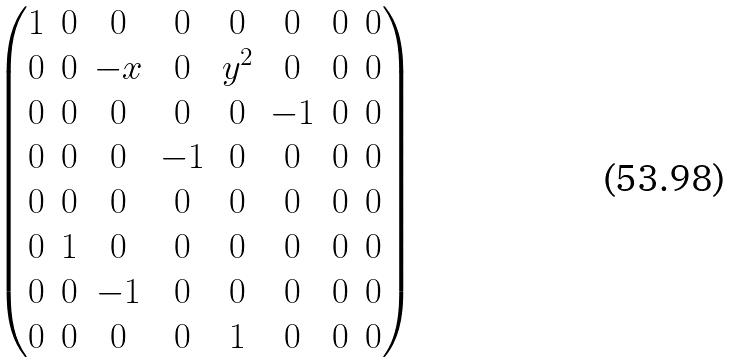Convert formula to latex. <formula><loc_0><loc_0><loc_500><loc_500>\begin{pmatrix} 1 & 0 & 0 & 0 & 0 & 0 & 0 & 0 \\ 0 & 0 & - x & 0 & y ^ { 2 } & 0 & 0 & 0 \\ 0 & 0 & 0 & 0 & 0 & - 1 & 0 & 0 \\ 0 & 0 & 0 & - 1 & 0 & 0 & 0 & 0 \\ 0 & 0 & 0 & 0 & 0 & 0 & 0 & 0 \\ 0 & 1 & 0 & 0 & 0 & 0 & 0 & 0 \\ 0 & 0 & - 1 & 0 & 0 & 0 & 0 & 0 \\ 0 & 0 & 0 & 0 & 1 & 0 & 0 & 0 \end{pmatrix}</formula> 